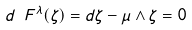<formula> <loc_0><loc_0><loc_500><loc_500>d _ { \ } F ^ { \lambda } ( \zeta ) = d \zeta - \mu \wedge \zeta = 0</formula> 